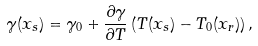Convert formula to latex. <formula><loc_0><loc_0><loc_500><loc_500>\gamma ( { x } _ { s } ) = \gamma _ { 0 } + \frac { \partial \gamma } { \partial T } \left ( T ( { x } _ { s } ) - T _ { 0 } ( { x } _ { r } ) \right ) ,</formula> 